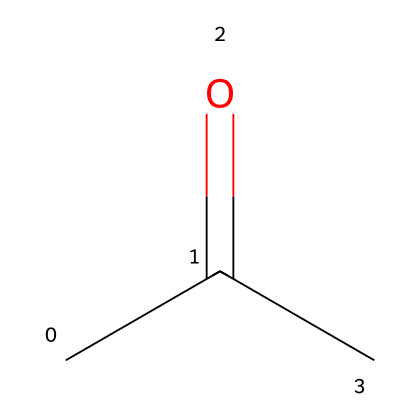What is the molecular formula of acetone? The SMILES representation CC(=O)C tells us that acetone consists of 3 carbon atoms (the "C"s), 6 hydrogen atoms (from the hydrogens implied with each carbon), and 1 oxygen atom (from the "=O"). Thus, the molecular formula can be derived as C3H6O.
Answer: C3H6O How many carbon atoms are in acetone? By examining the SMILES CC(=O)C, we can count the instances of "C" which represents carbon, leading us to 3 carbon atoms in total.
Answer: 3 What type of functional group is present in acetone? The presence of the "=O" in the chemical structure indicates a carbonyl group, which classifies acetone as a ketone.
Answer: ketone What is the total number of valence electrons for acetone? Carbon has 4 valence electrons, hydrogen has 1, and oxygen has 6. Summing the valence electrons for 3 carbons (3x4=12), 6 hydrogens (6x1=6), and 1 oxygen (1x6=6) gives us a total of 24 valence electrons.
Answer: 24 What type of solvent is acetone commonly used as? Acetone is widely recognized as an organic solvent, often used in nail polish remover due to its ability to dissolve various substances.
Answer: organic solvent How many hydrogen atoms are present in acetone? From the SMILES structure, we observe there are 6 hydrogens surrounding the 3 carbon atoms and the 1 oxygen, specifying that acetone contains 6 hydrogen atoms in total.
Answer: 6 